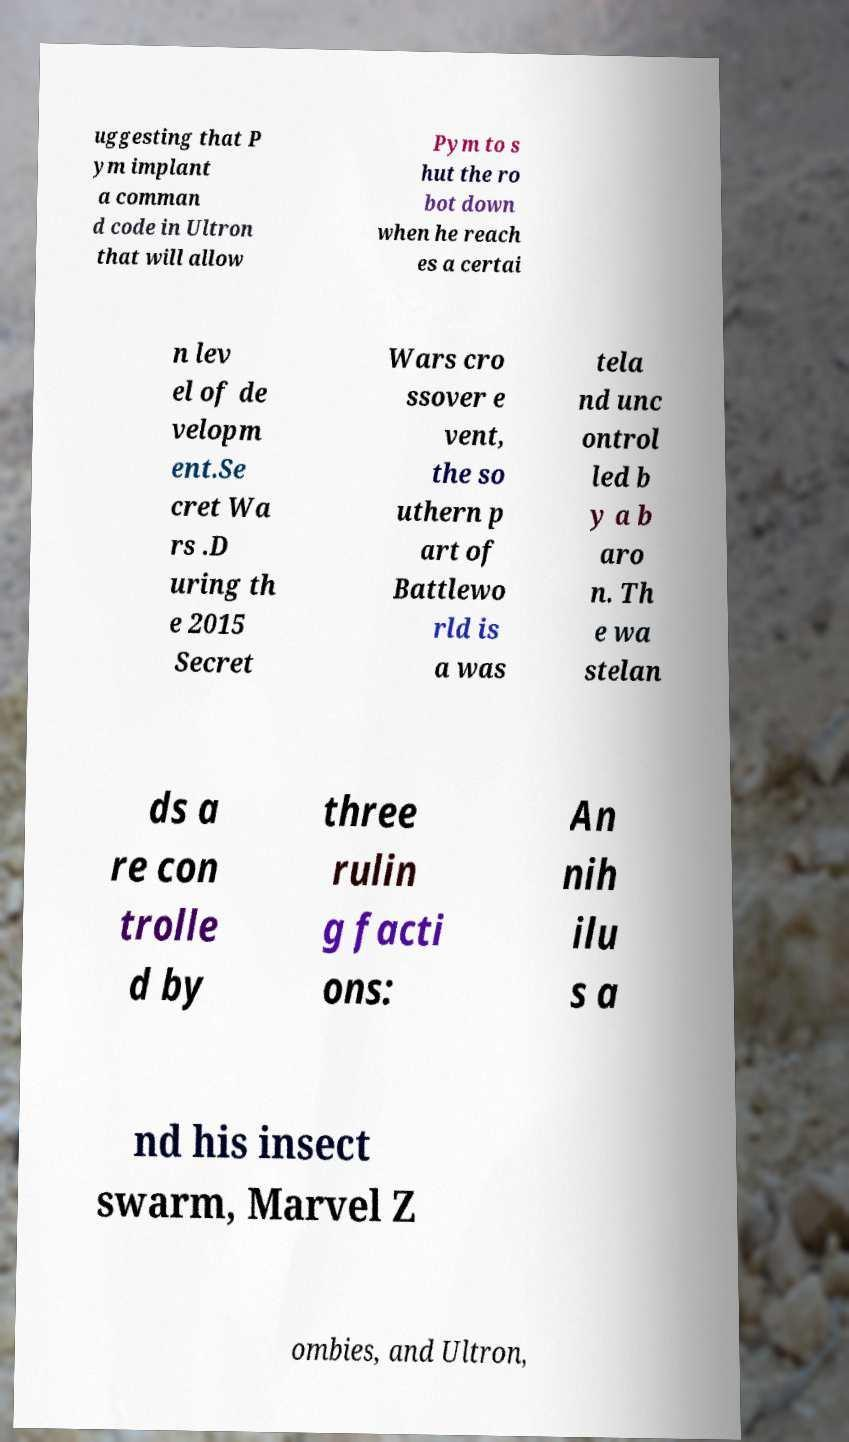Could you extract and type out the text from this image? uggesting that P ym implant a comman d code in Ultron that will allow Pym to s hut the ro bot down when he reach es a certai n lev el of de velopm ent.Se cret Wa rs .D uring th e 2015 Secret Wars cro ssover e vent, the so uthern p art of Battlewo rld is a was tela nd unc ontrol led b y a b aro n. Th e wa stelan ds a re con trolle d by three rulin g facti ons: An nih ilu s a nd his insect swarm, Marvel Z ombies, and Ultron, 